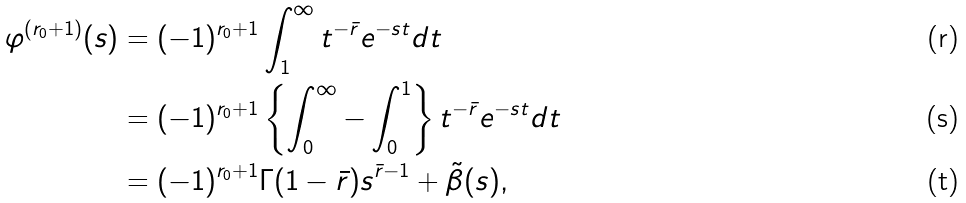Convert formula to latex. <formula><loc_0><loc_0><loc_500><loc_500>\varphi ^ { ( r _ { 0 } + 1 ) } ( s ) & = ( - 1 ) ^ { r _ { 0 } + 1 } \int _ { 1 } ^ { \infty } t ^ { - \bar { r } } e ^ { - s t } d t \\ & = ( - 1 ) ^ { r _ { 0 } + 1 } \left \{ \int _ { 0 } ^ { \infty } - \int _ { 0 } ^ { 1 } \right \} t ^ { - \bar { r } } e ^ { - s t } d t \\ & = ( - 1 ) ^ { r _ { 0 } + 1 } \Gamma ( 1 - \bar { r } ) s ^ { \bar { r } - 1 } + \tilde { \beta } ( s ) ,</formula> 